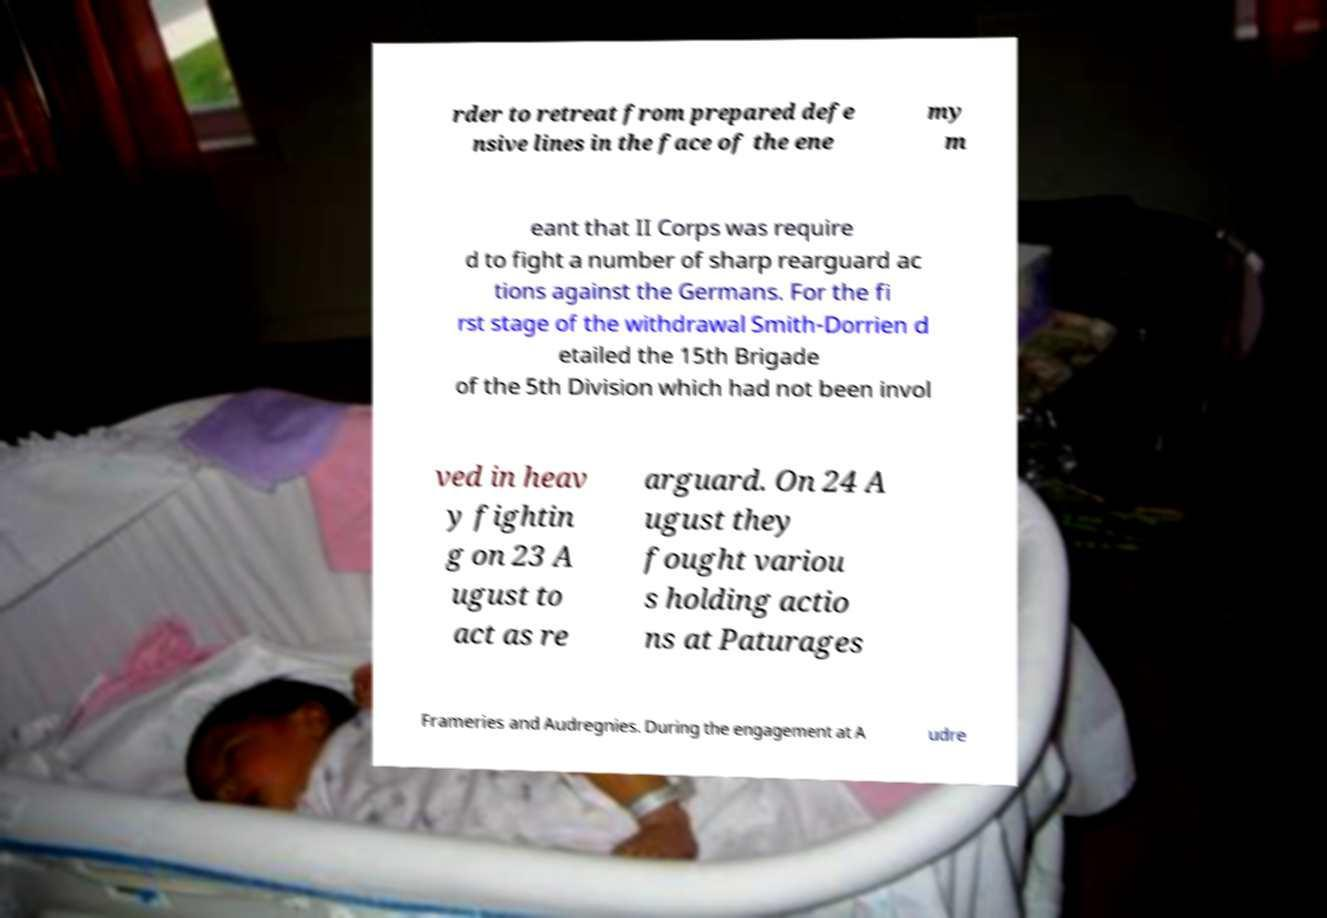Can you accurately transcribe the text from the provided image for me? rder to retreat from prepared defe nsive lines in the face of the ene my m eant that II Corps was require d to fight a number of sharp rearguard ac tions against the Germans. For the fi rst stage of the withdrawal Smith-Dorrien d etailed the 15th Brigade of the 5th Division which had not been invol ved in heav y fightin g on 23 A ugust to act as re arguard. On 24 A ugust they fought variou s holding actio ns at Paturages Frameries and Audregnies. During the engagement at A udre 